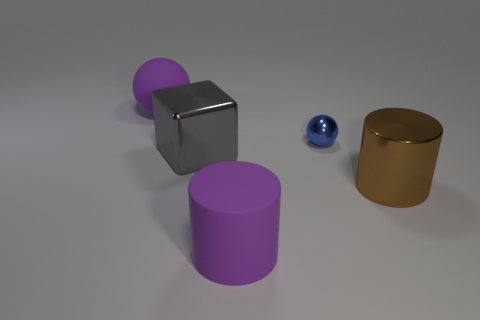The matte thing right of the purple matte thing behind the purple object in front of the brown cylinder is what color?
Your answer should be very brief. Purple. Is the material of the ball in front of the purple ball the same as the large purple thing in front of the tiny object?
Keep it short and to the point. No. How many objects are either big things on the right side of the big purple rubber ball or large purple rubber blocks?
Keep it short and to the point. 3. How many objects are tiny green shiny spheres or objects that are right of the big purple matte cylinder?
Your response must be concise. 2. What number of gray shiny cubes have the same size as the matte cylinder?
Ensure brevity in your answer.  1. Is the number of tiny blue shiny spheres in front of the metallic block less than the number of purple matte objects that are in front of the large brown thing?
Offer a very short reply. Yes. What number of matte things are gray objects or big yellow things?
Offer a very short reply. 0. The small blue metal object has what shape?
Offer a very short reply. Sphere. There is a purple ball that is the same size as the purple cylinder; what material is it?
Provide a short and direct response. Rubber. How many tiny objects are either rubber things or metallic cylinders?
Keep it short and to the point. 0. 